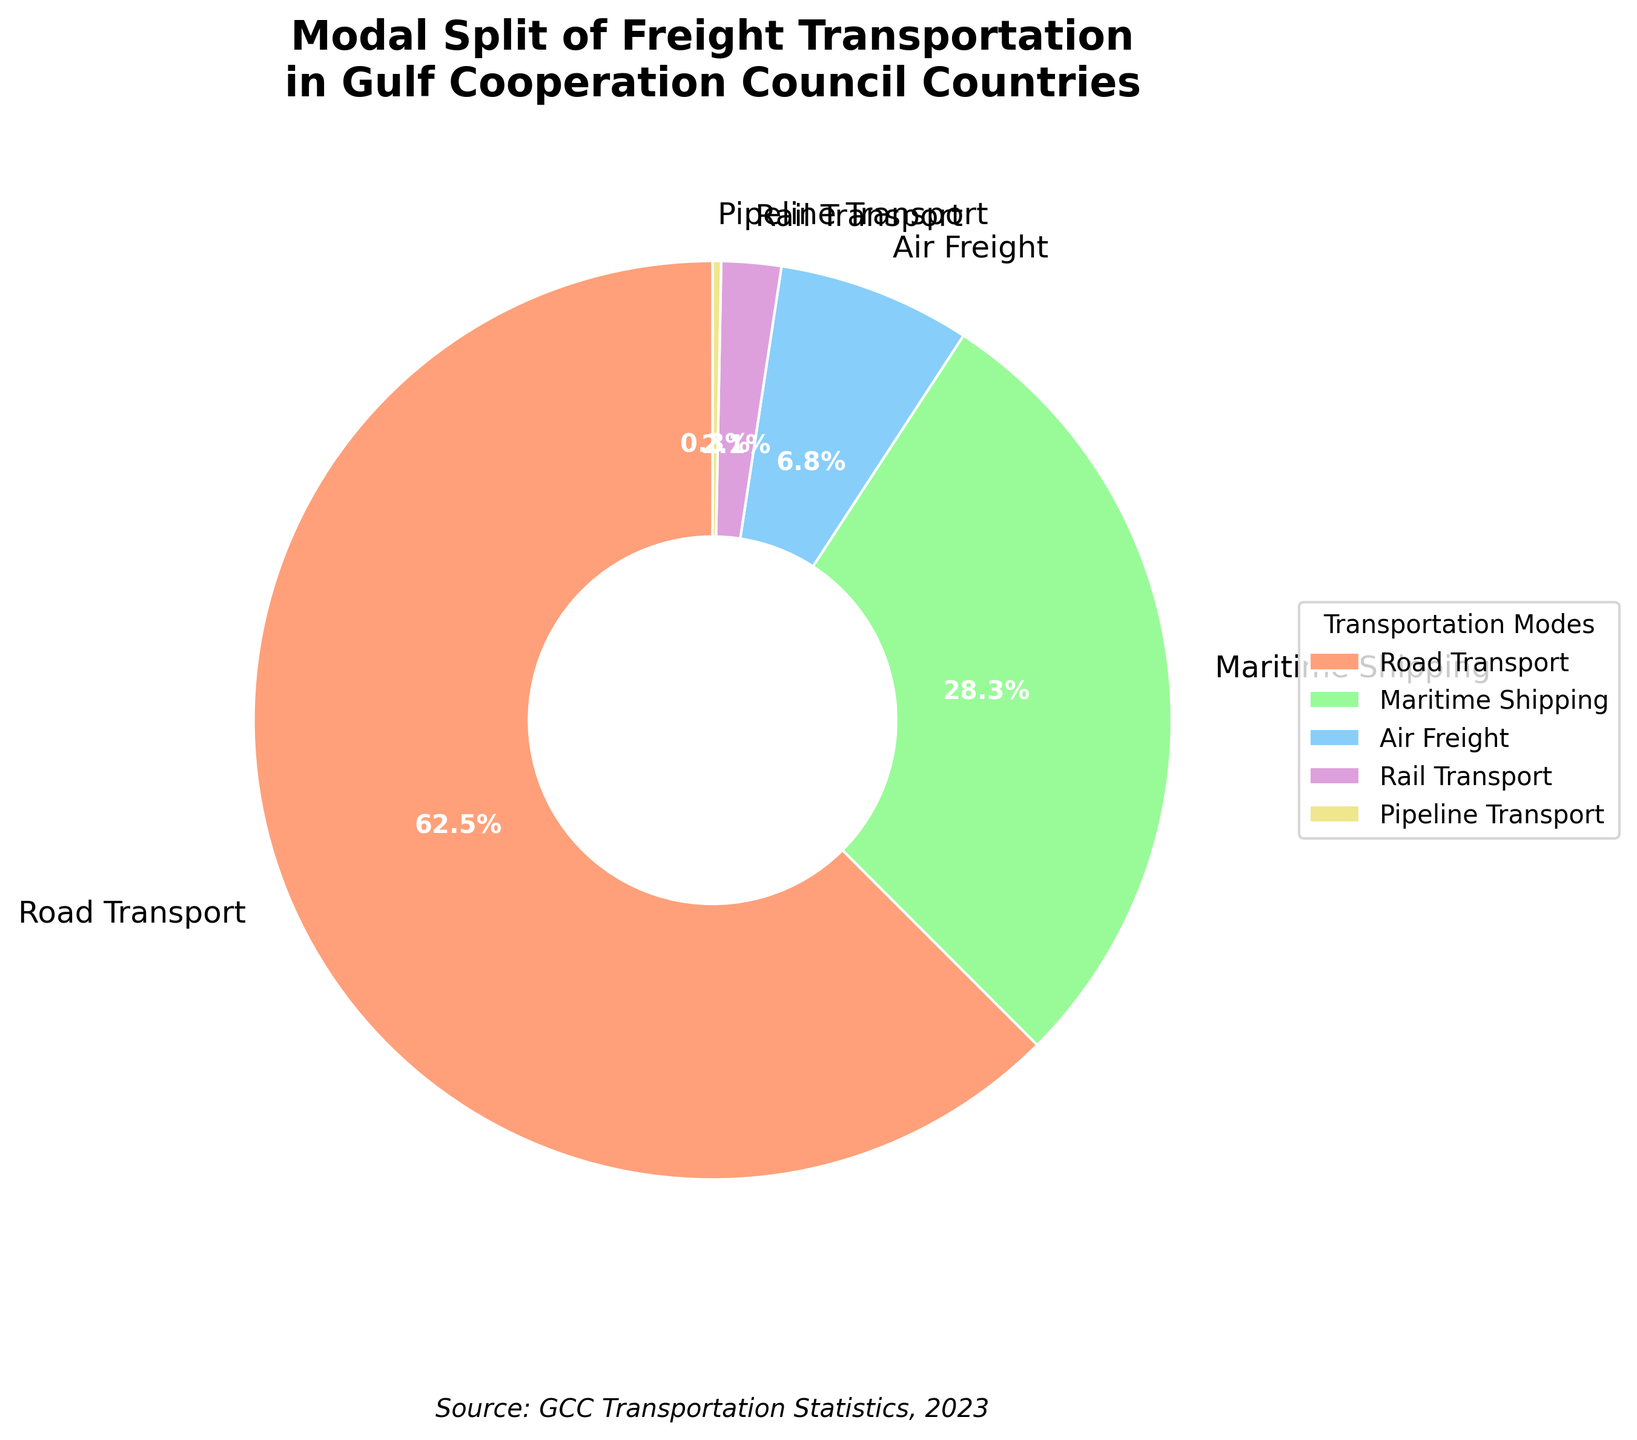Which mode of transportation is used the most for freight transportation in GCC countries? By looking at the pie chart, we can see that the largest segment represents Road Transport with 62.5%.
Answer: Road Transport What is the combined percentage of Maritime Shipping and Air Freight? To find the combined percentage, sum the percentages of Maritime Shipping and Air Freight: 28.3% + 6.8% = 35.1%.
Answer: 35.1% Which mode of transportation has the least usage percentage in GCC countries? Observing the segments of the pie chart, the smallest segment is Pipeline Transport with 0.3%.
Answer: Pipeline Transport How much more freight transportation is handled by Road Transport compared to Rail Transport? Subtract the percentage of Rail Transport from the percentage of Road Transport: 62.5% - 2.1% = 60.4%.
Answer: 60.4% Is the percentage of Air Freight more than twice that of Rail Transport? Twice the Rail Transport percentage is 2.1% * 2 = 4.2%. Since Air Freight is 6.8%, which is greater than 4.2%, the answer is yes.
Answer: Yes How much higher is the percentage of Road Transport compared to the combined percentage of Air Freight and Pipeline Transport? First, find the combined percentage of Air Freight and Pipeline Transport: 6.8% + 0.3% = 7.1%. Then, subtract this from the Road Transport percentage: 62.5% - 7.1% = 55.4%.
Answer: 55.4% What is the average percentage of the four least used modes of transportation? Sum the percentages of Maritime Shipping (28.3%), Air Freight (6.8%), Rail Transport (2.1%), and Pipeline Transport (0.3%), then divide by 4: (28.3% + 6.8% + 2.1% + 0.3%) / 4 = 9.375%.
Answer: 9.375% Which transportation mode is represented by the light blue color? By matching the colors from the pie chart with the transportation modes, the light blue color corresponds to Air Freight.
Answer: Air Freight Compare the total transportation handled by Road Transport and Maritime Shipping. Is one more than double the other? First, double the Maritime Shipping percentage: 28.3% * 2 = 56.6%. Since 62.5% (Road Transport) is greater than 56.6%, Road Transport is more than double Maritime Shipping.
Answer: Yes 